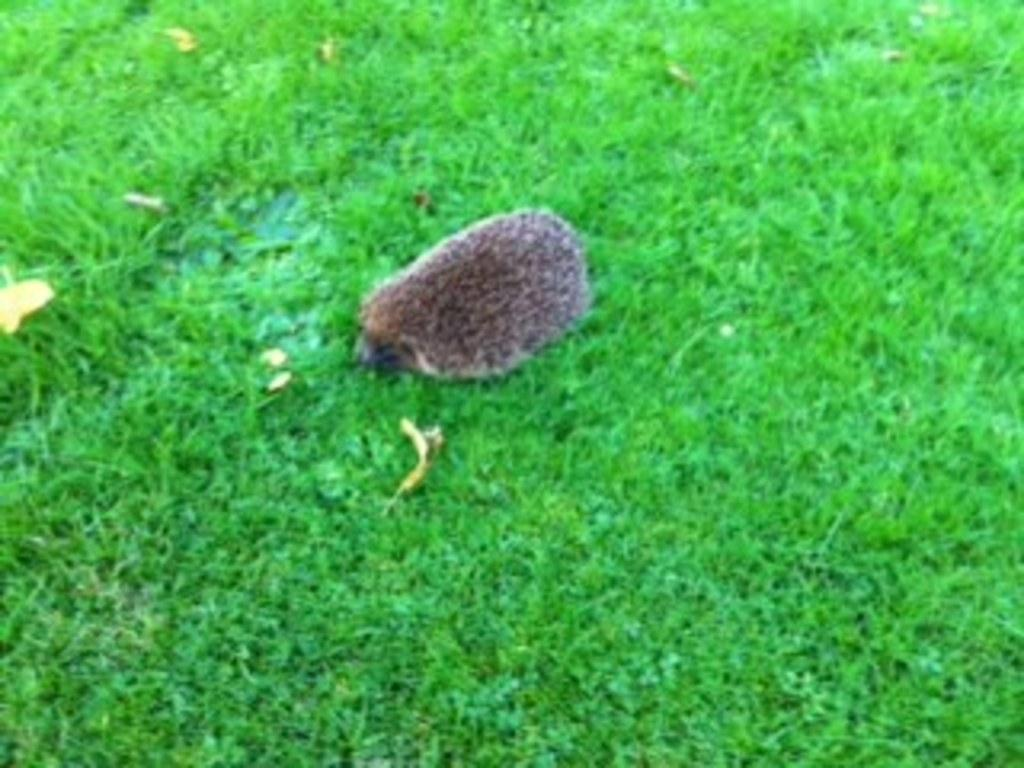What type of animal can be seen in the image? There is an animal on the grass in the image. What time of day is it in the image, and what type of pen is the animal using to write its thoughts? The time of day cannot be determined from the image, and there is no pen or writing activity present in the image. 